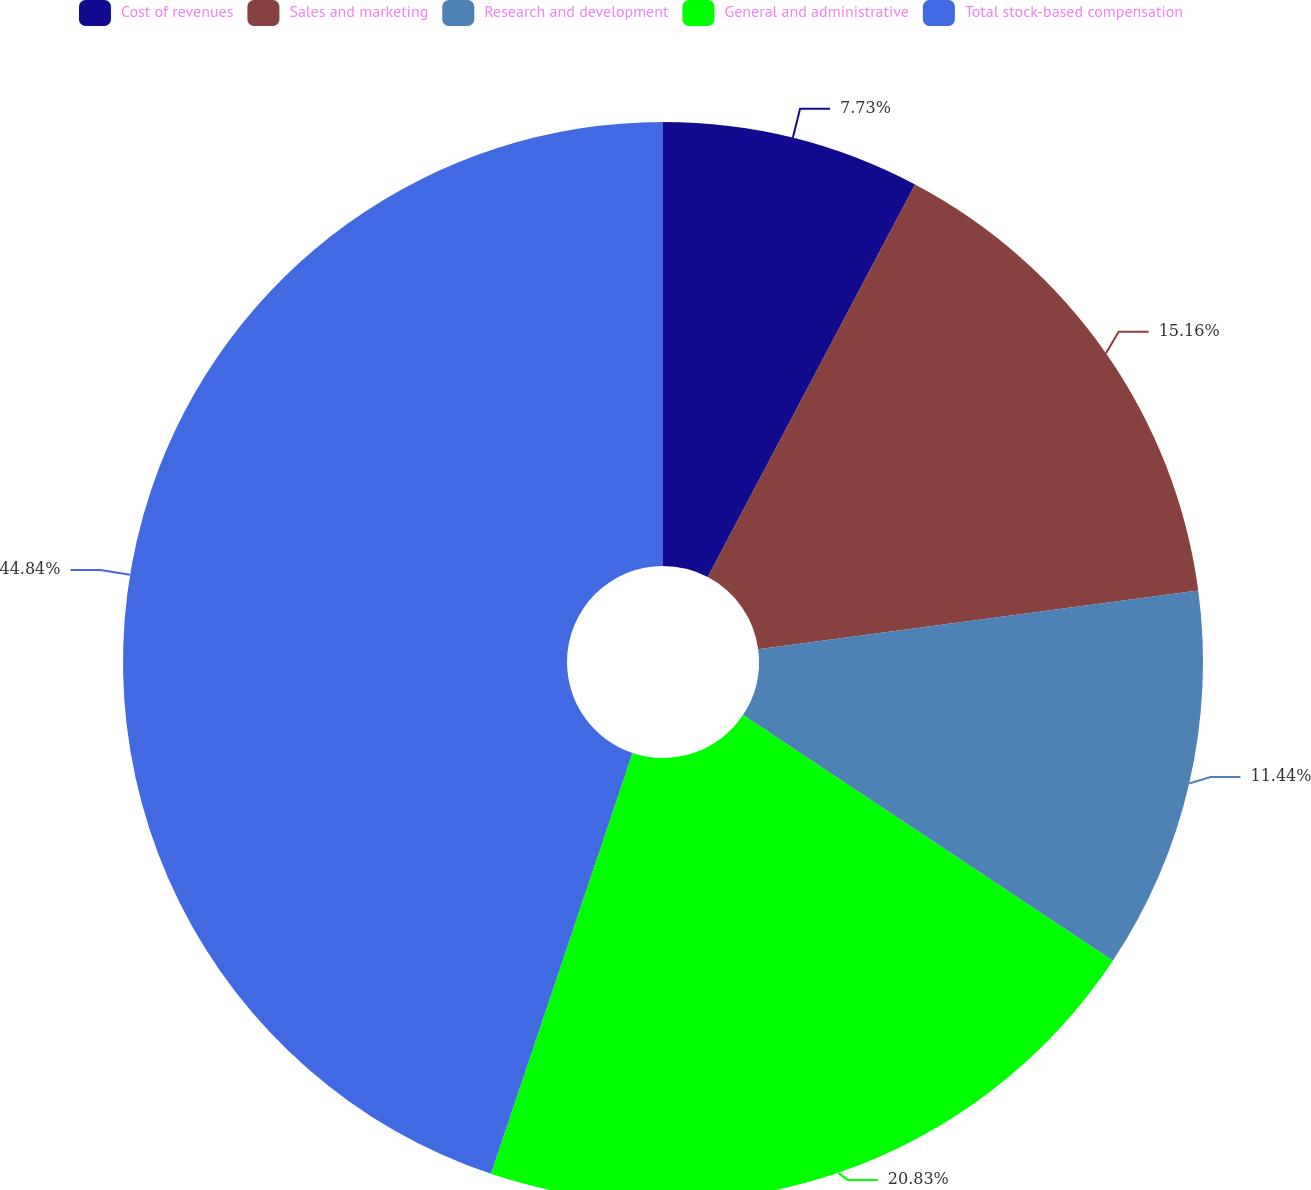<chart> <loc_0><loc_0><loc_500><loc_500><pie_chart><fcel>Cost of revenues<fcel>Sales and marketing<fcel>Research and development<fcel>General and administrative<fcel>Total stock-based compensation<nl><fcel>7.73%<fcel>15.16%<fcel>11.44%<fcel>20.83%<fcel>44.84%<nl></chart> 